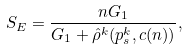Convert formula to latex. <formula><loc_0><loc_0><loc_500><loc_500>S _ { E } = \frac { n G _ { 1 } } { G _ { 1 } + \hat { \rho } ^ { k } ( p _ { s } ^ { k } , c ( n ) ) } ,</formula> 